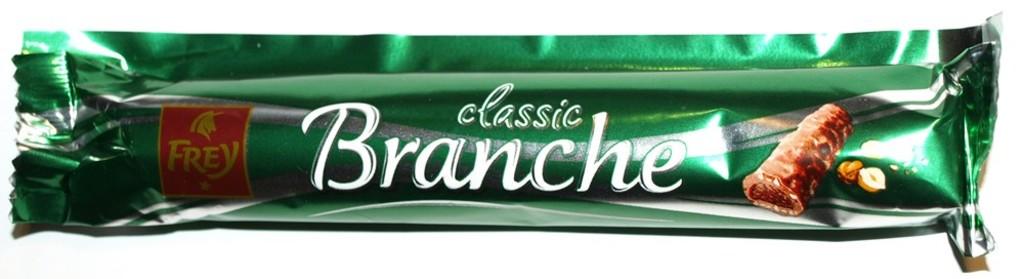Which brand is featured?
Make the answer very short. Frey. What is the brand name of the candy bar?
Keep it short and to the point. Frey. 